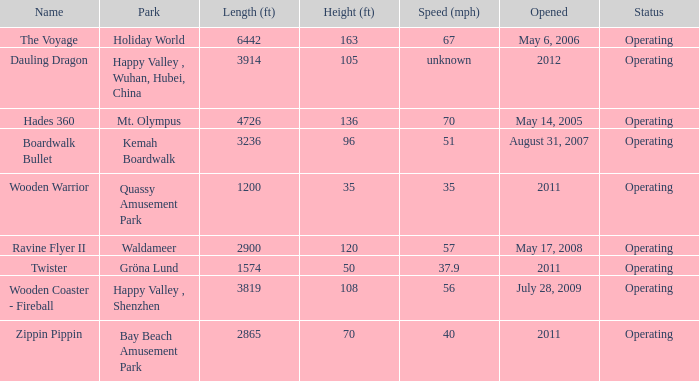How many parks is Zippin Pippin located in 1.0. 